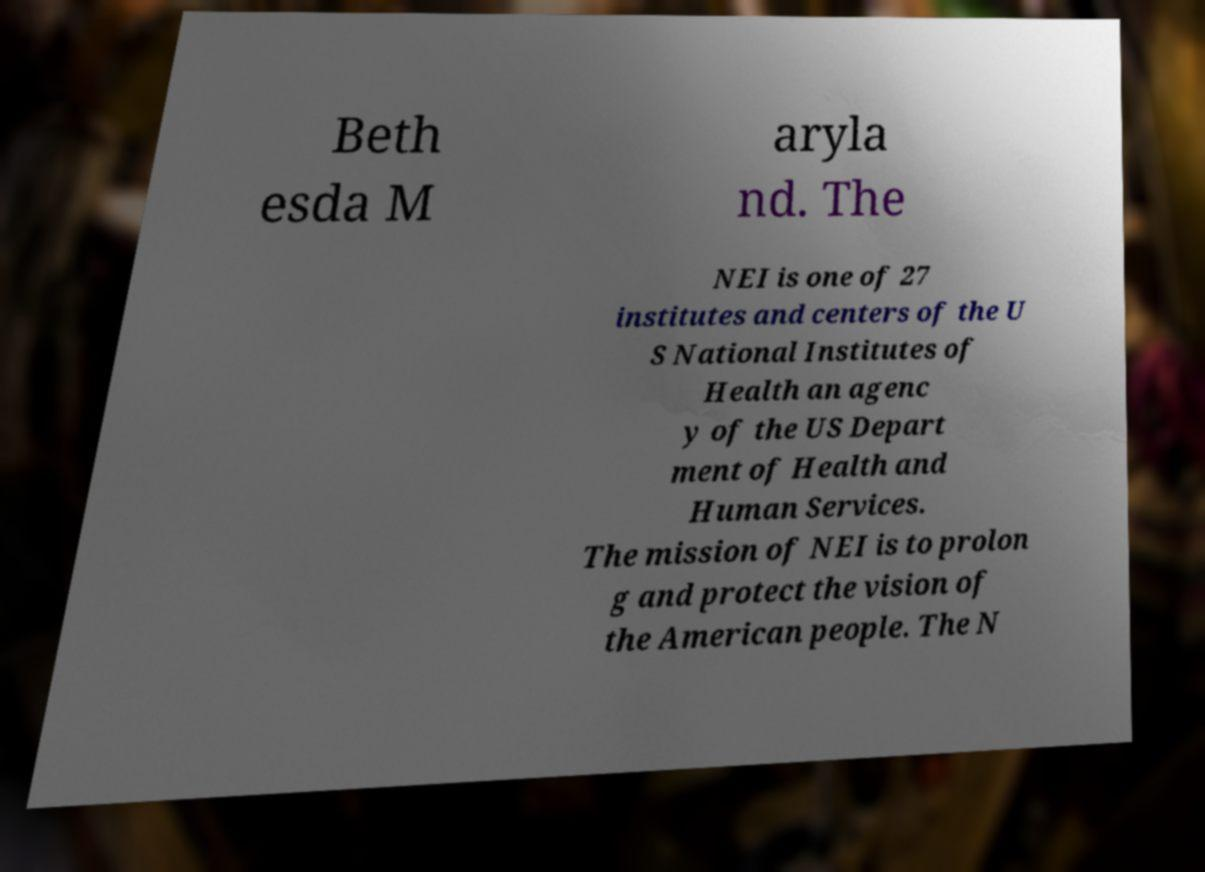Please identify and transcribe the text found in this image. Beth esda M aryla nd. The NEI is one of 27 institutes and centers of the U S National Institutes of Health an agenc y of the US Depart ment of Health and Human Services. The mission of NEI is to prolon g and protect the vision of the American people. The N 